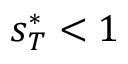<formula> <loc_0><loc_0><loc_500><loc_500>s _ { T } ^ { * } < 1</formula> 